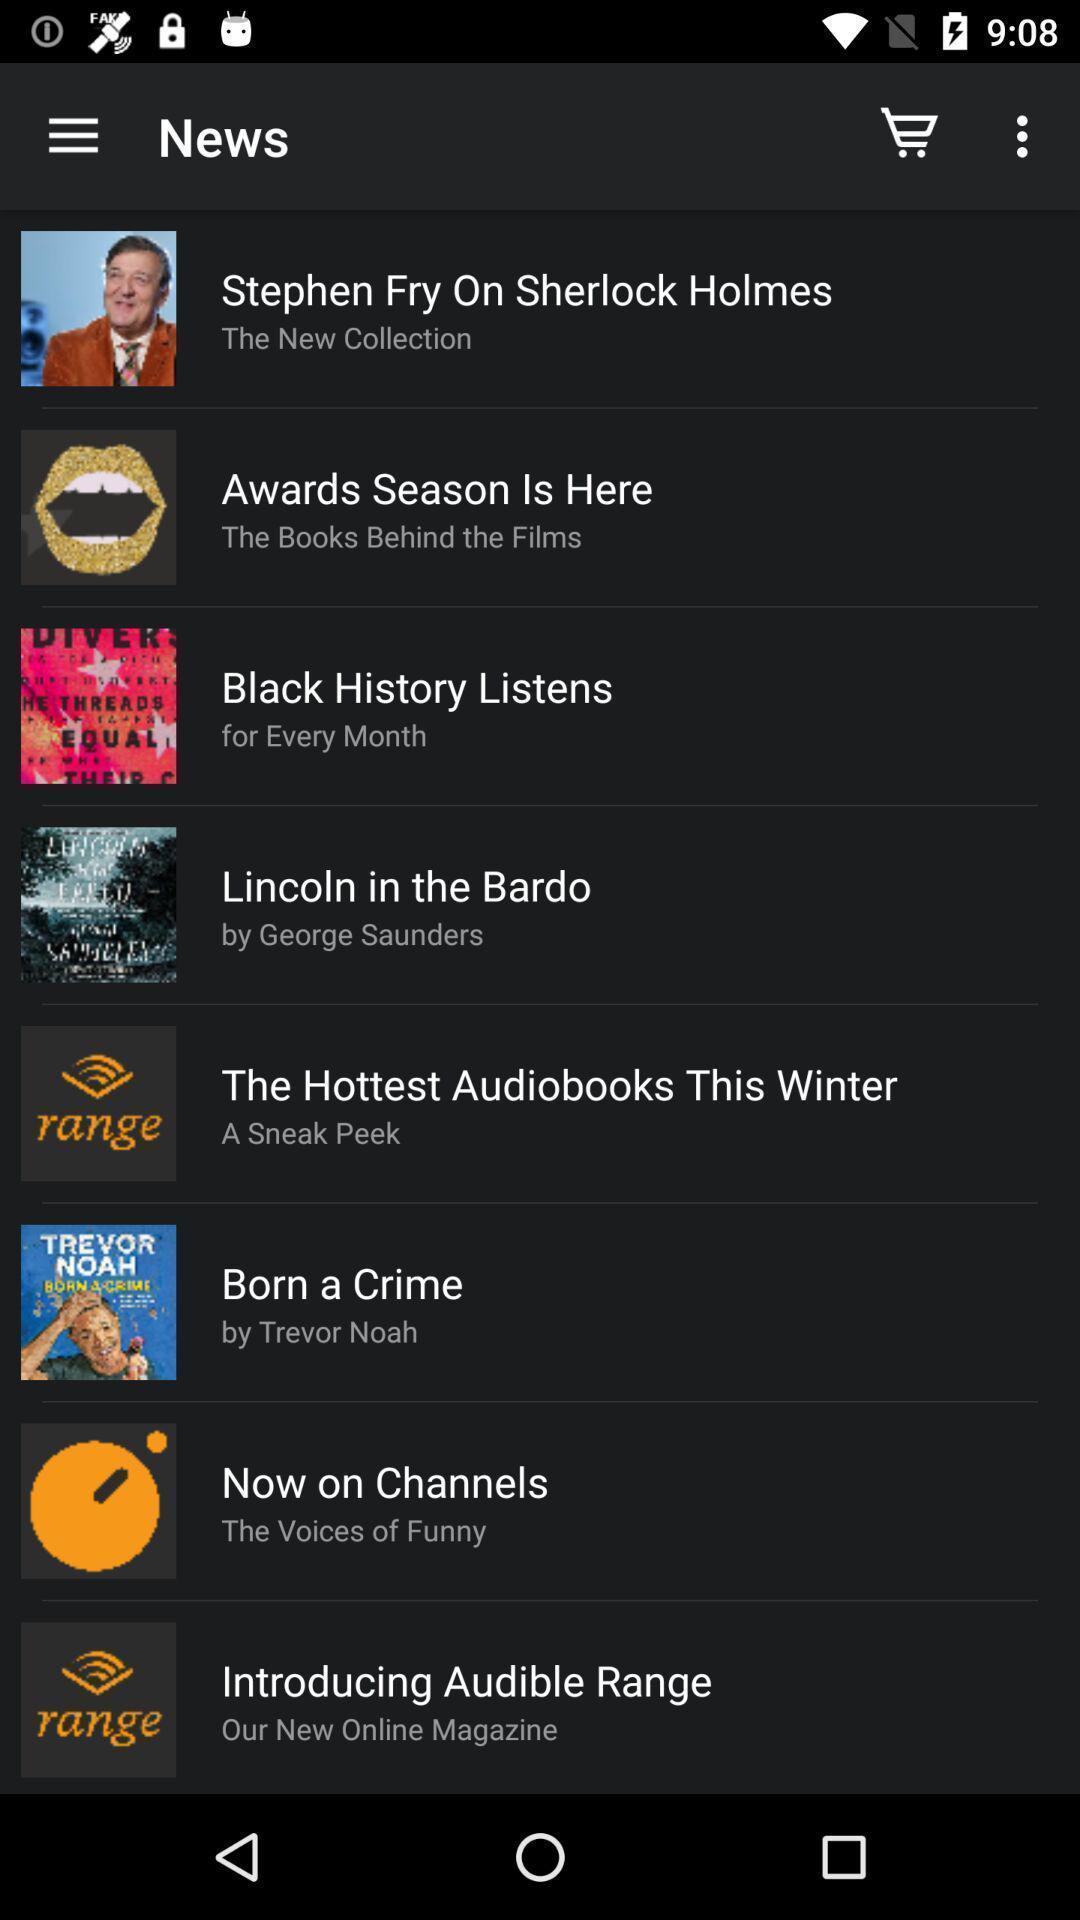What details can you identify in this image? Page shows the news and few other articles. 